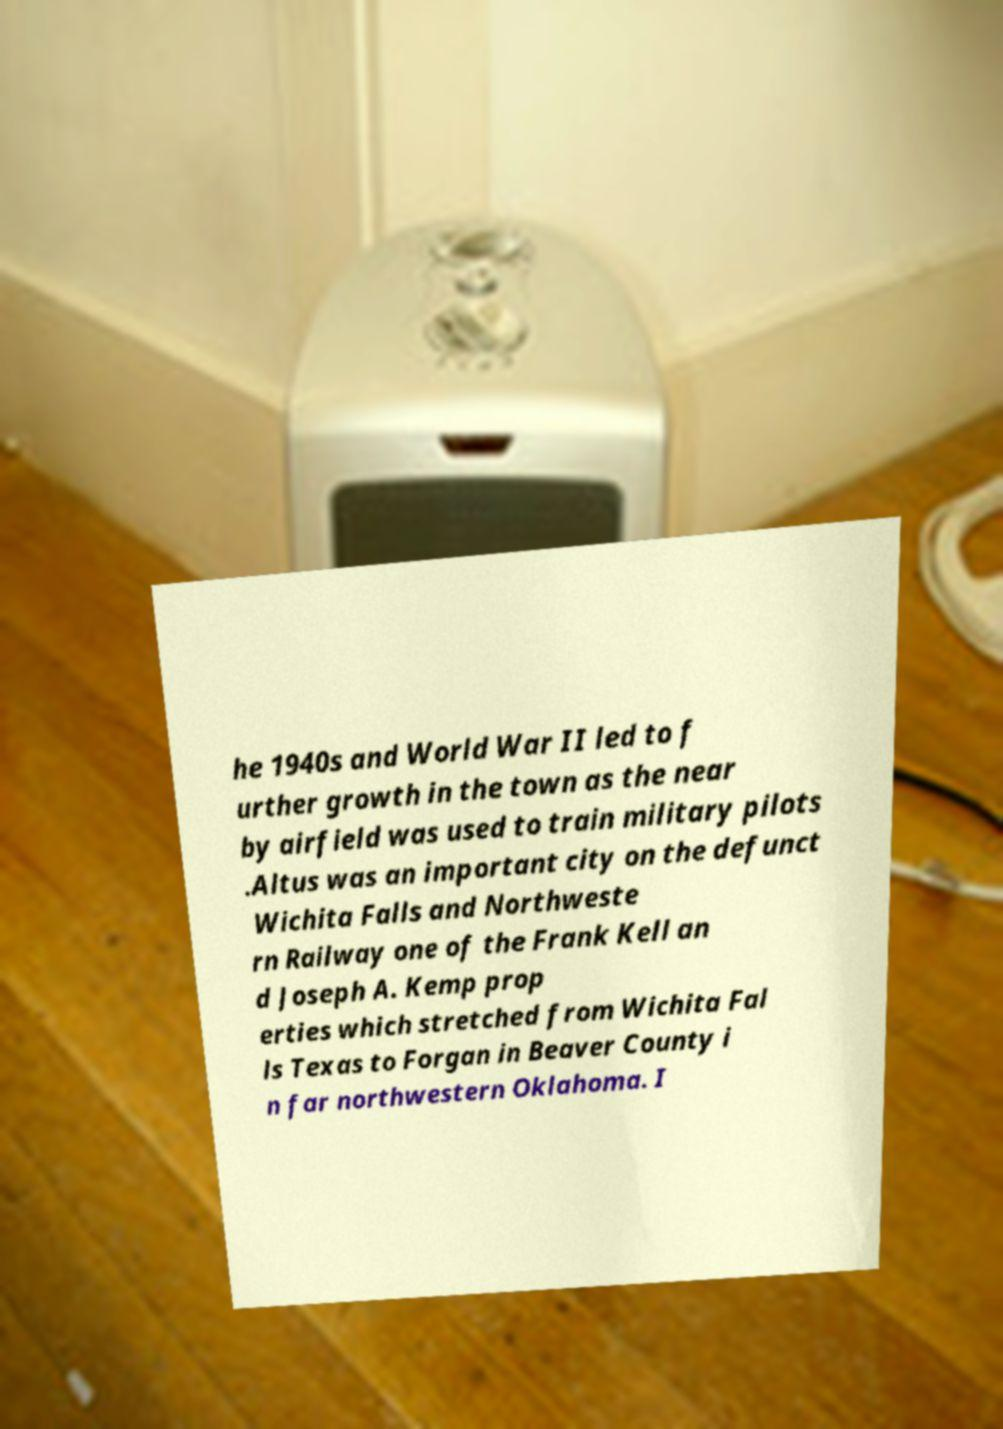Could you extract and type out the text from this image? he 1940s and World War II led to f urther growth in the town as the near by airfield was used to train military pilots .Altus was an important city on the defunct Wichita Falls and Northweste rn Railway one of the Frank Kell an d Joseph A. Kemp prop erties which stretched from Wichita Fal ls Texas to Forgan in Beaver County i n far northwestern Oklahoma. I 